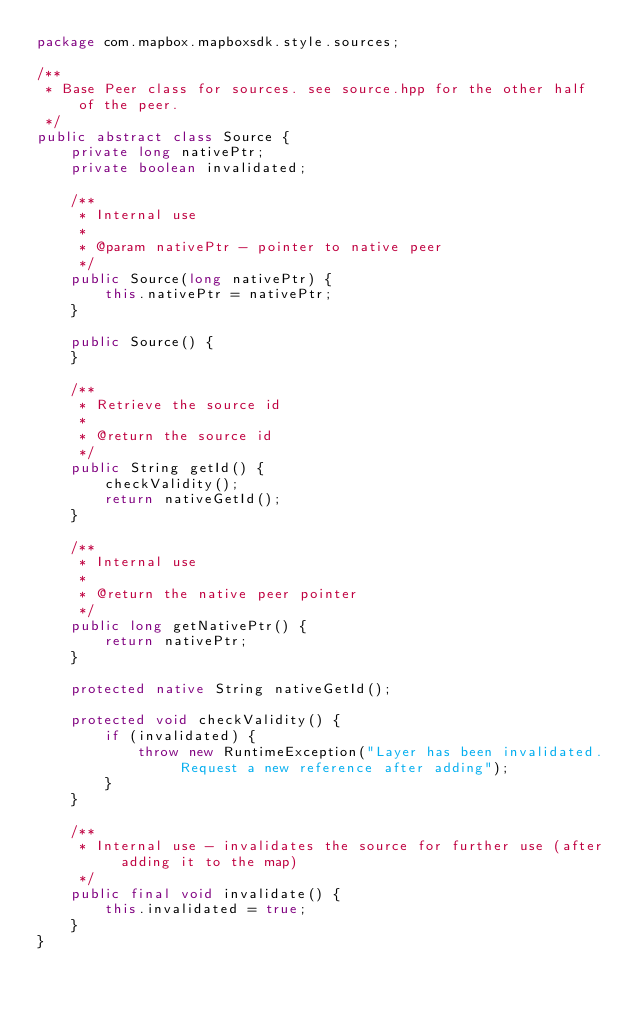<code> <loc_0><loc_0><loc_500><loc_500><_Java_>package com.mapbox.mapboxsdk.style.sources;

/**
 * Base Peer class for sources. see source.hpp for the other half of the peer.
 */
public abstract class Source {
    private long nativePtr;
    private boolean invalidated;

    /**
     * Internal use
     *
     * @param nativePtr - pointer to native peer
     */
    public Source(long nativePtr) {
        this.nativePtr = nativePtr;
    }

    public Source() {
    }

    /**
     * Retrieve the source id
     *
     * @return the source id
     */
    public String getId() {
        checkValidity();
        return nativeGetId();
    }

    /**
     * Internal use
     *
     * @return the native peer pointer
     */
    public long getNativePtr() {
        return nativePtr;
    }

    protected native String nativeGetId();

    protected void checkValidity() {
        if (invalidated) {
            throw new RuntimeException("Layer has been invalidated. Request a new reference after adding");
        }
    }

    /**
     * Internal use - invalidates the source for further use (after adding it to the map)
     */
    public final void invalidate() {
        this.invalidated = true;
    }
}
</code> 